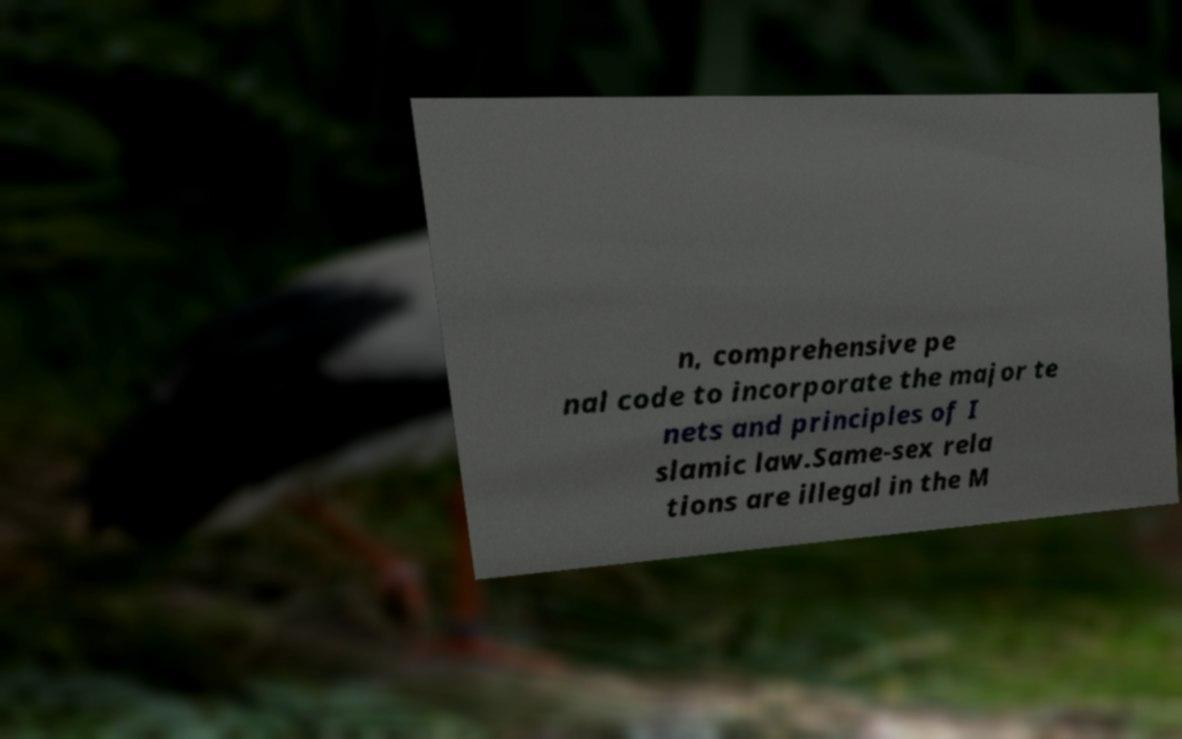What messages or text are displayed in this image? I need them in a readable, typed format. n, comprehensive pe nal code to incorporate the major te nets and principles of I slamic law.Same-sex rela tions are illegal in the M 